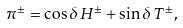<formula> <loc_0><loc_0><loc_500><loc_500>\pi ^ { \pm } = \cos \delta \, H ^ { \pm } + \sin \delta \, T ^ { \pm } ,</formula> 